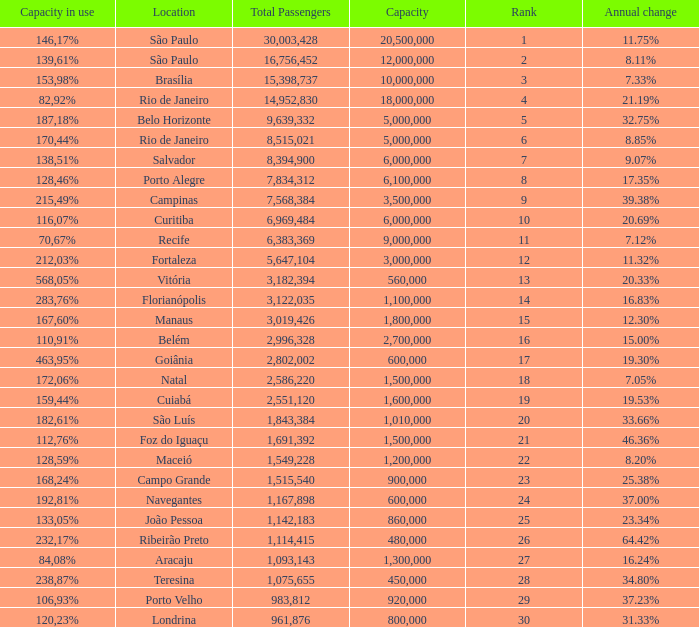Which location has a capacity that has a rank of 23? 168,24%. 